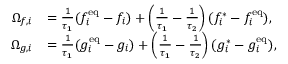Convert formula to latex. <formula><loc_0><loc_0><loc_500><loc_500>\begin{array} { r l } { \Omega _ { f , i } } & { = \frac { 1 } { \tau _ { 1 } } ( f _ { i } ^ { e q } - f _ { i } ) + \left ( \frac { 1 } { \tau _ { 1 } } - \frac { 1 } { \tau _ { 2 } } \right ) ( f _ { i } ^ { \ast } - f _ { i } ^ { e q } ) , } \\ { \Omega _ { g , i } } & { = \frac { 1 } { \tau _ { 1 } } ( g _ { i } ^ { e q } - g _ { i } ) + \left ( \frac { 1 } { \tau _ { 1 } } - \frac { 1 } { \tau _ { 2 } } \right ) ( g _ { i } ^ { \ast } - g _ { i } ^ { e q } ) , } \end{array}</formula> 